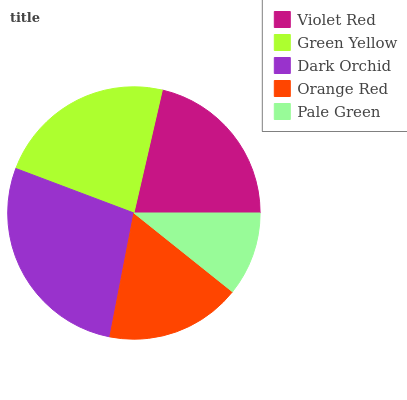Is Pale Green the minimum?
Answer yes or no. Yes. Is Dark Orchid the maximum?
Answer yes or no. Yes. Is Green Yellow the minimum?
Answer yes or no. No. Is Green Yellow the maximum?
Answer yes or no. No. Is Green Yellow greater than Violet Red?
Answer yes or no. Yes. Is Violet Red less than Green Yellow?
Answer yes or no. Yes. Is Violet Red greater than Green Yellow?
Answer yes or no. No. Is Green Yellow less than Violet Red?
Answer yes or no. No. Is Violet Red the high median?
Answer yes or no. Yes. Is Violet Red the low median?
Answer yes or no. Yes. Is Orange Red the high median?
Answer yes or no. No. Is Pale Green the low median?
Answer yes or no. No. 